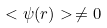Convert formula to latex. <formula><loc_0><loc_0><loc_500><loc_500>< \psi ( { r } ) > \, \neq 0</formula> 